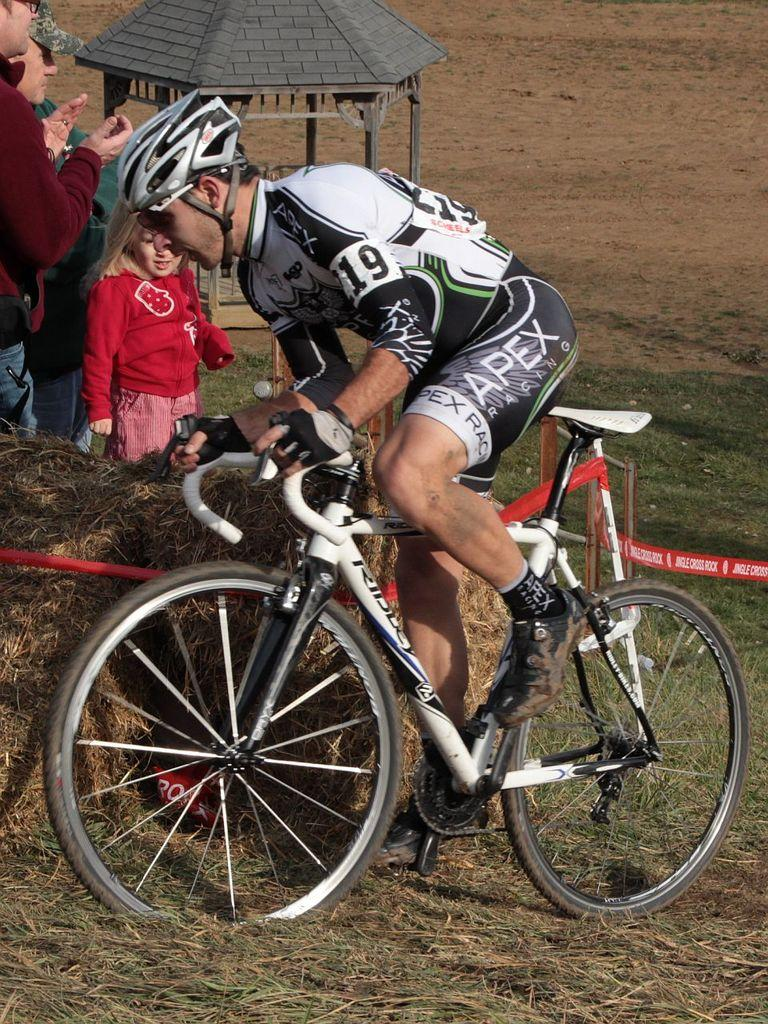What is the man in the image doing? The man in the image is riding a bicycle. Are there any other people in the image? Yes, there is a group of people standing beside the man on the bicycle. What structure can be seen in the image? There is a tent present in the image. What type of texture can be seen on the doll in the image? There is no doll present in the image, so it is not possible to determine the texture of a doll. 